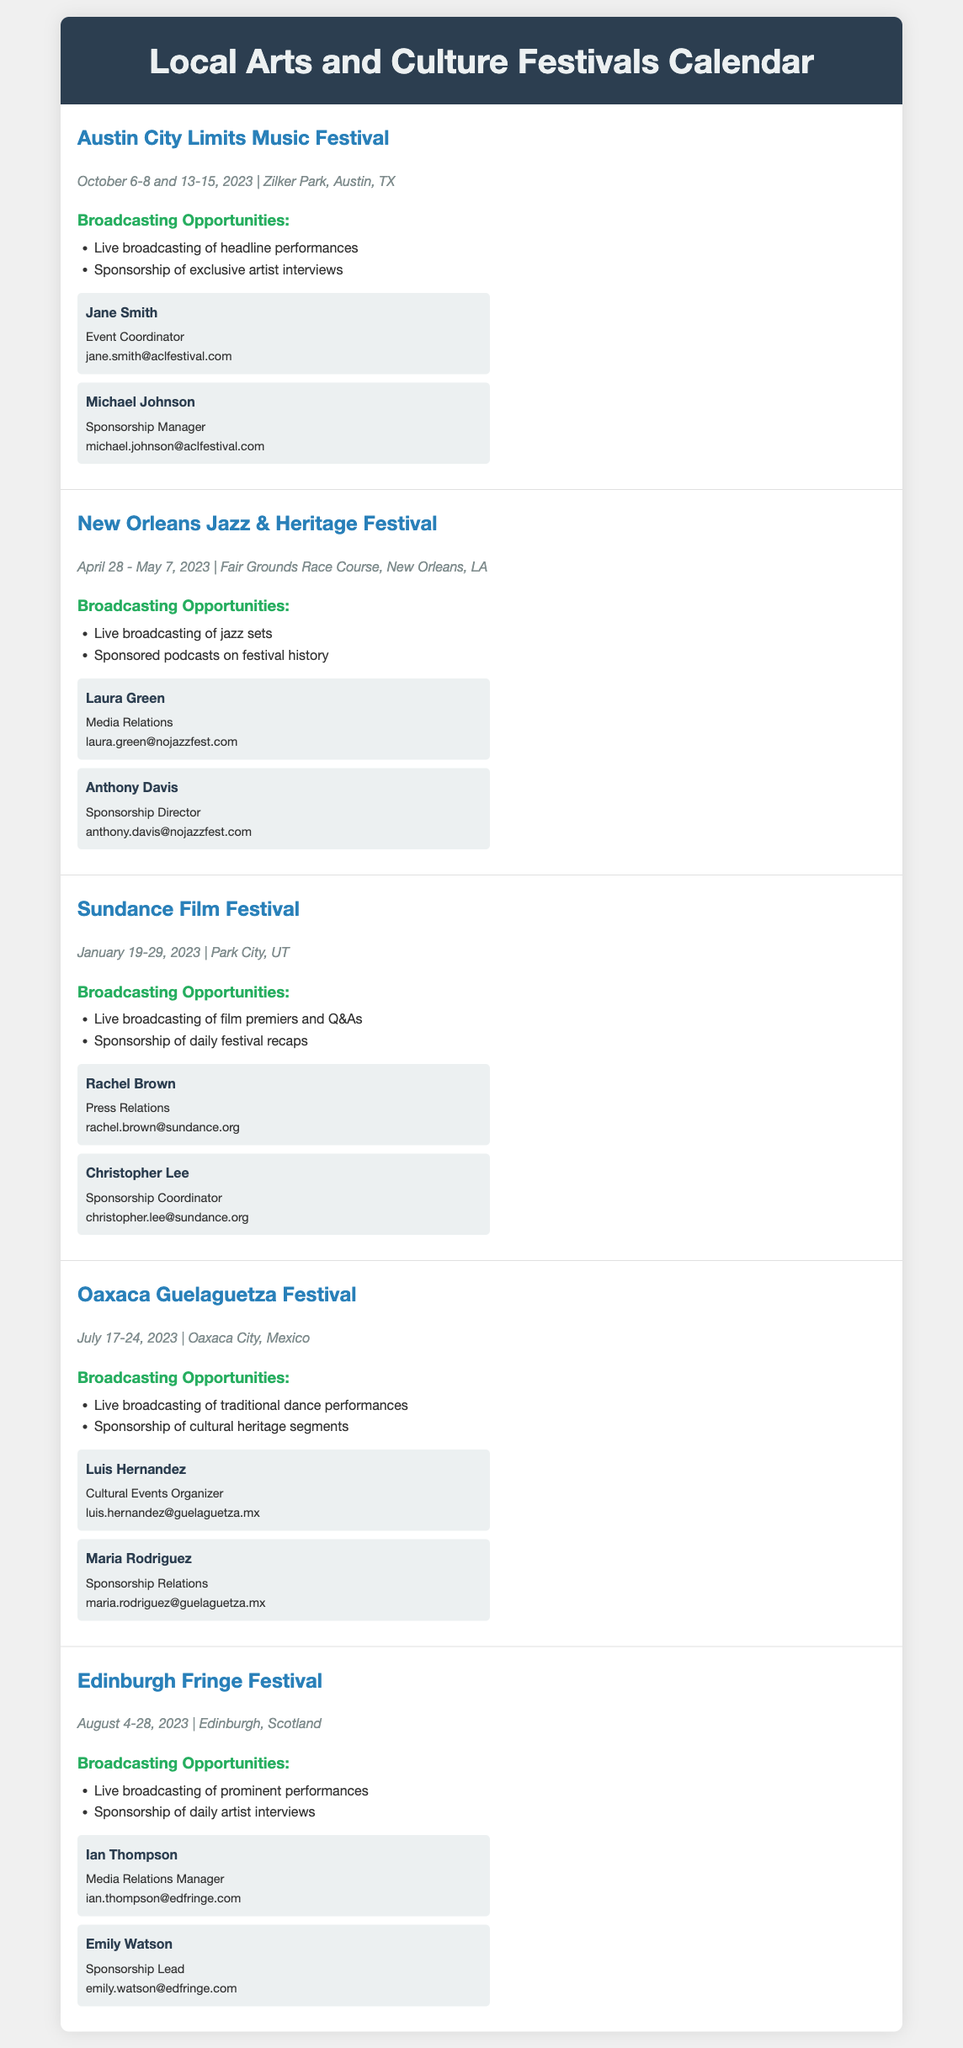What are the dates for the Austin City Limits Music Festival? The dates are explicitly mentioned in the festival section as October 6-8 and 13-15, 2023.
Answer: October 6-8 and 13-15, 2023 Who is the event coordinator for the New Orleans Jazz & Heritage Festival? The document specifies Jane Smith as the event coordinator for the festival.
Answer: Laura Green What type of broadcasting opportunity is available at the Sundance Film Festival? The document lists live broadcasting of film premiers and Q&As as an opportunity.
Answer: Live broadcasting of film premiers and Q&As What is the location of the Oaxaca Guelaguetza Festival? The location is given in the festival section as Oaxaca City, Mexico.
Answer: Oaxaca City, Mexico How many days does the Edinburgh Fringe Festival last? The start date is August 4, 2023, and the end date is August 28, 2023, which is a total of 25 days.
Answer: 25 days Which festival has the earliest date in 2023? The Sundance Film Festival starts on January 19, 2023, making it the earliest among the listed festivals.
Answer: Sundance Film Festival What opportunity is offered for sponsorship at the Austin City Limits Music Festival? The document mentions sponsorship of exclusive artist interviews as one of the opportunities.
Answer: Sponsorship of exclusive artist interviews 